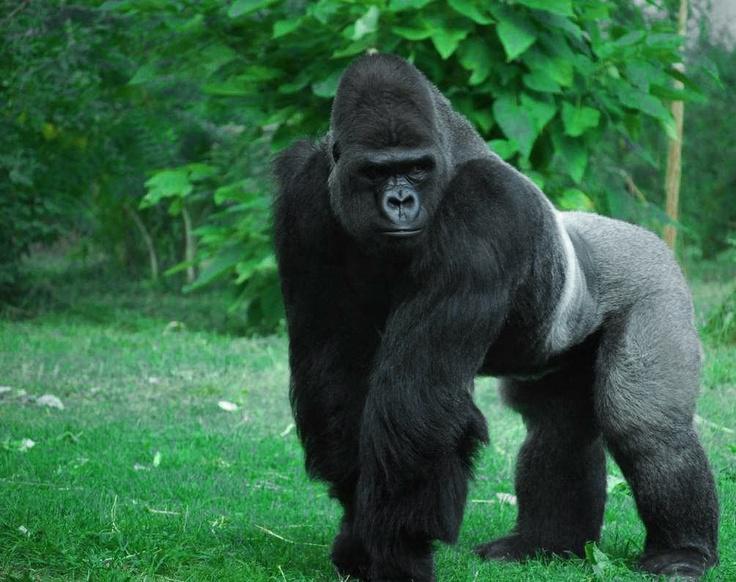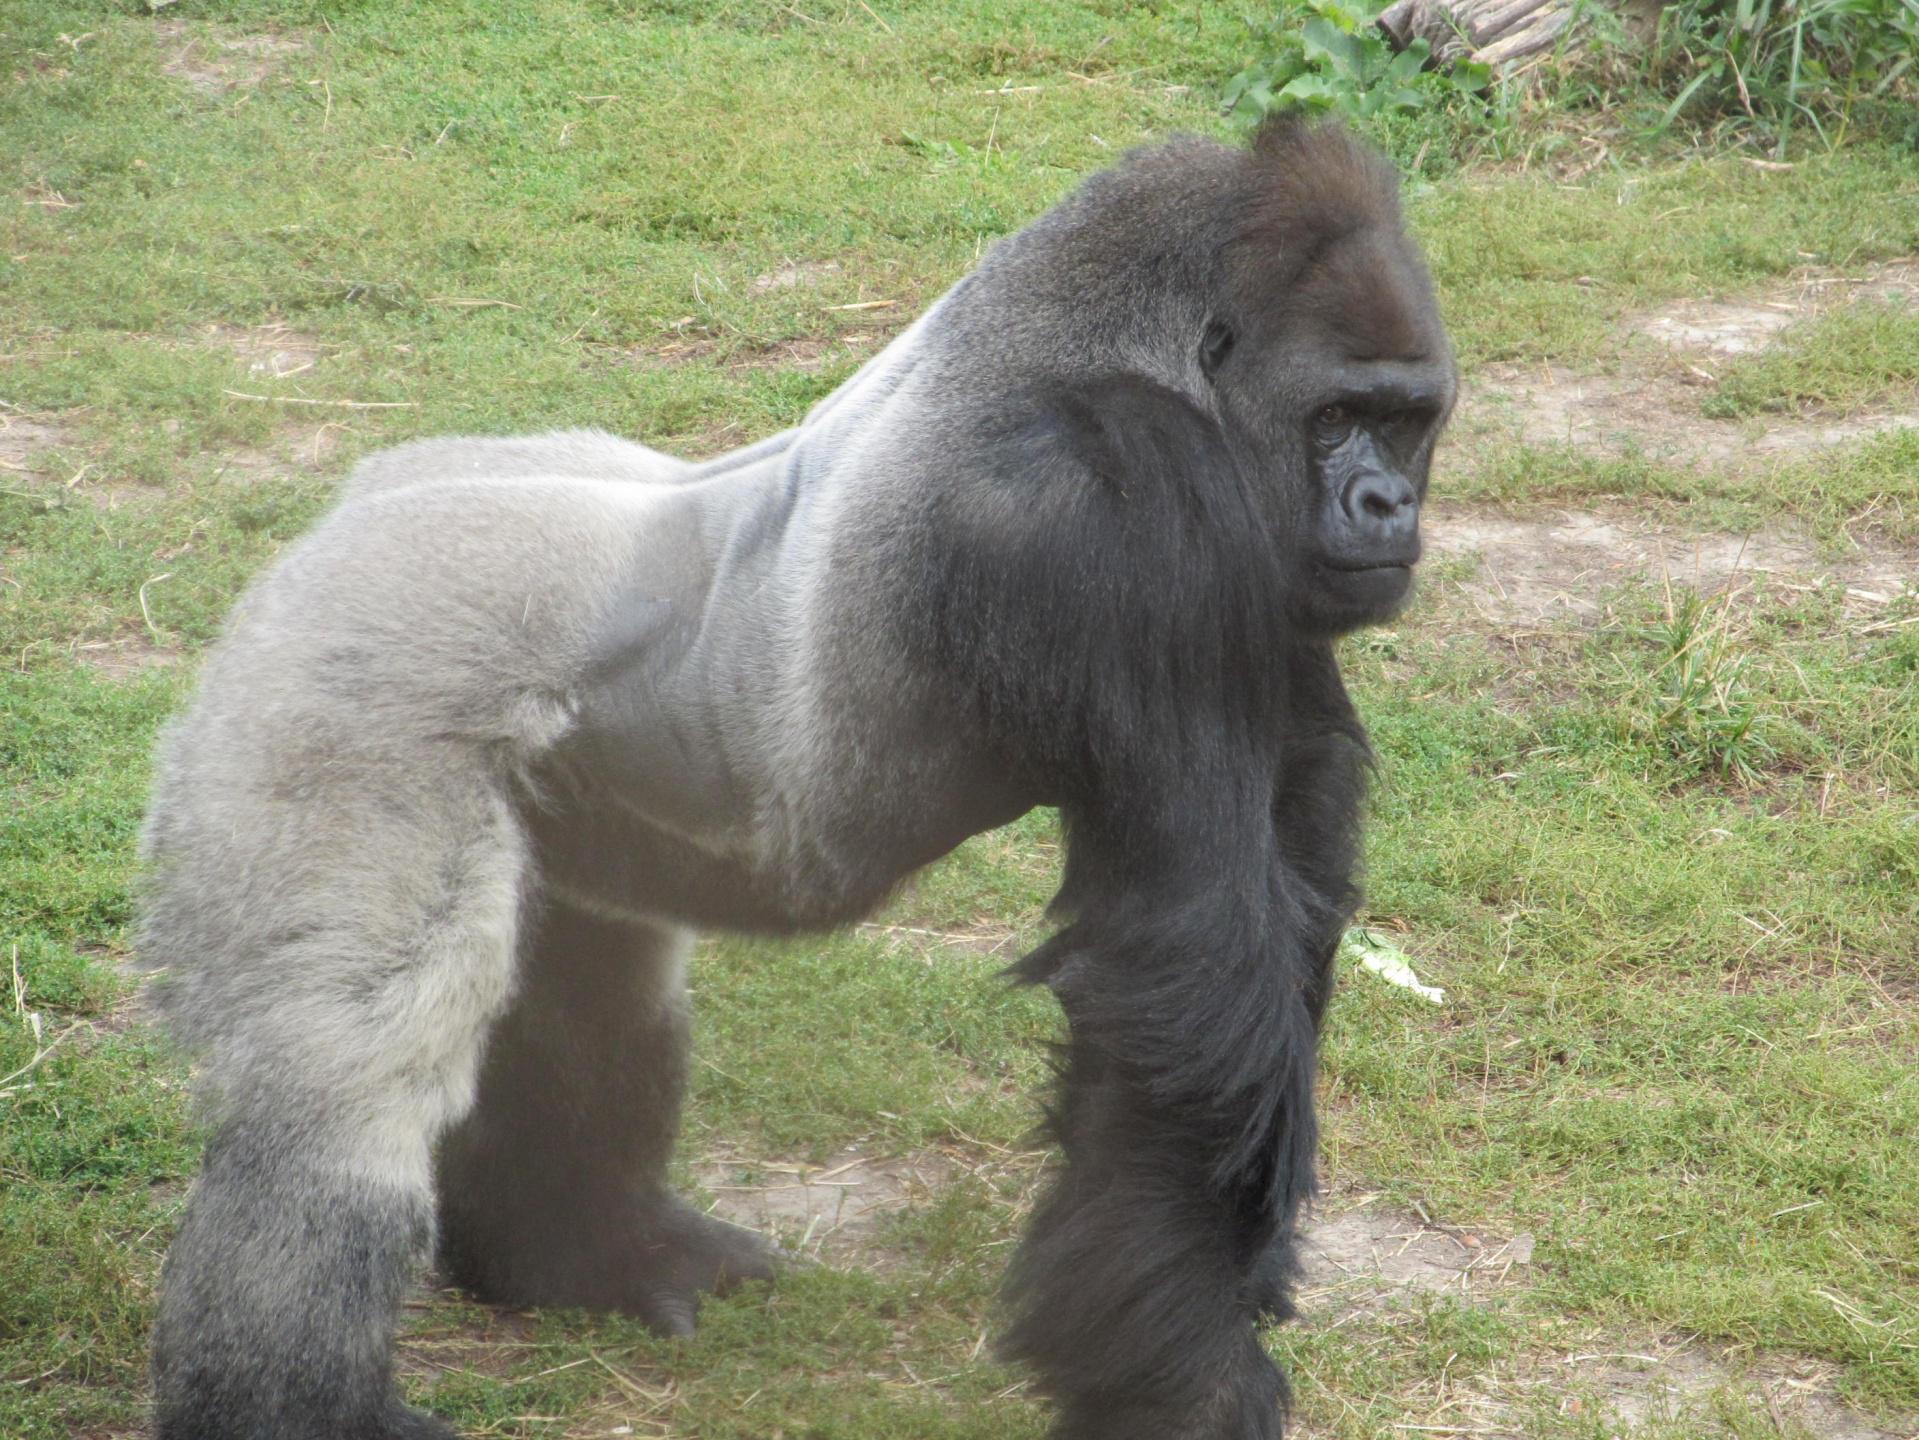The first image is the image on the left, the second image is the image on the right. For the images shown, is this caption "Two gorillas are bent forward, standing on all four feet." true? Answer yes or no. Yes. The first image is the image on the left, the second image is the image on the right. Given the left and right images, does the statement "All images show a gorilla standing on its legs and hands." hold true? Answer yes or no. Yes. 